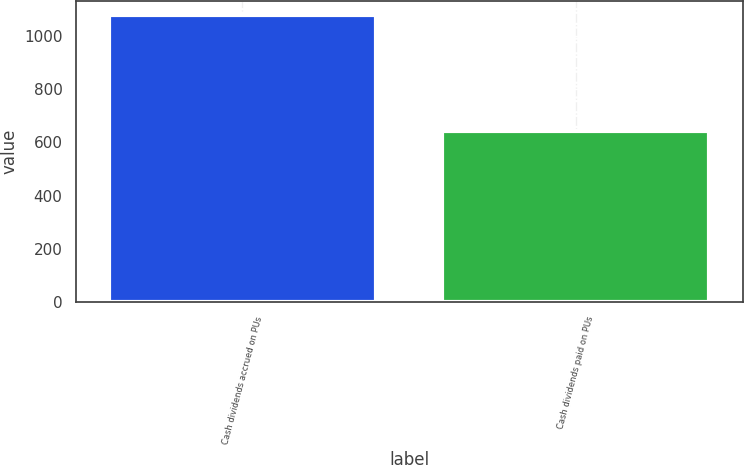Convert chart. <chart><loc_0><loc_0><loc_500><loc_500><bar_chart><fcel>Cash dividends accrued on PUs<fcel>Cash dividends paid on PUs<nl><fcel>1078<fcel>645<nl></chart> 